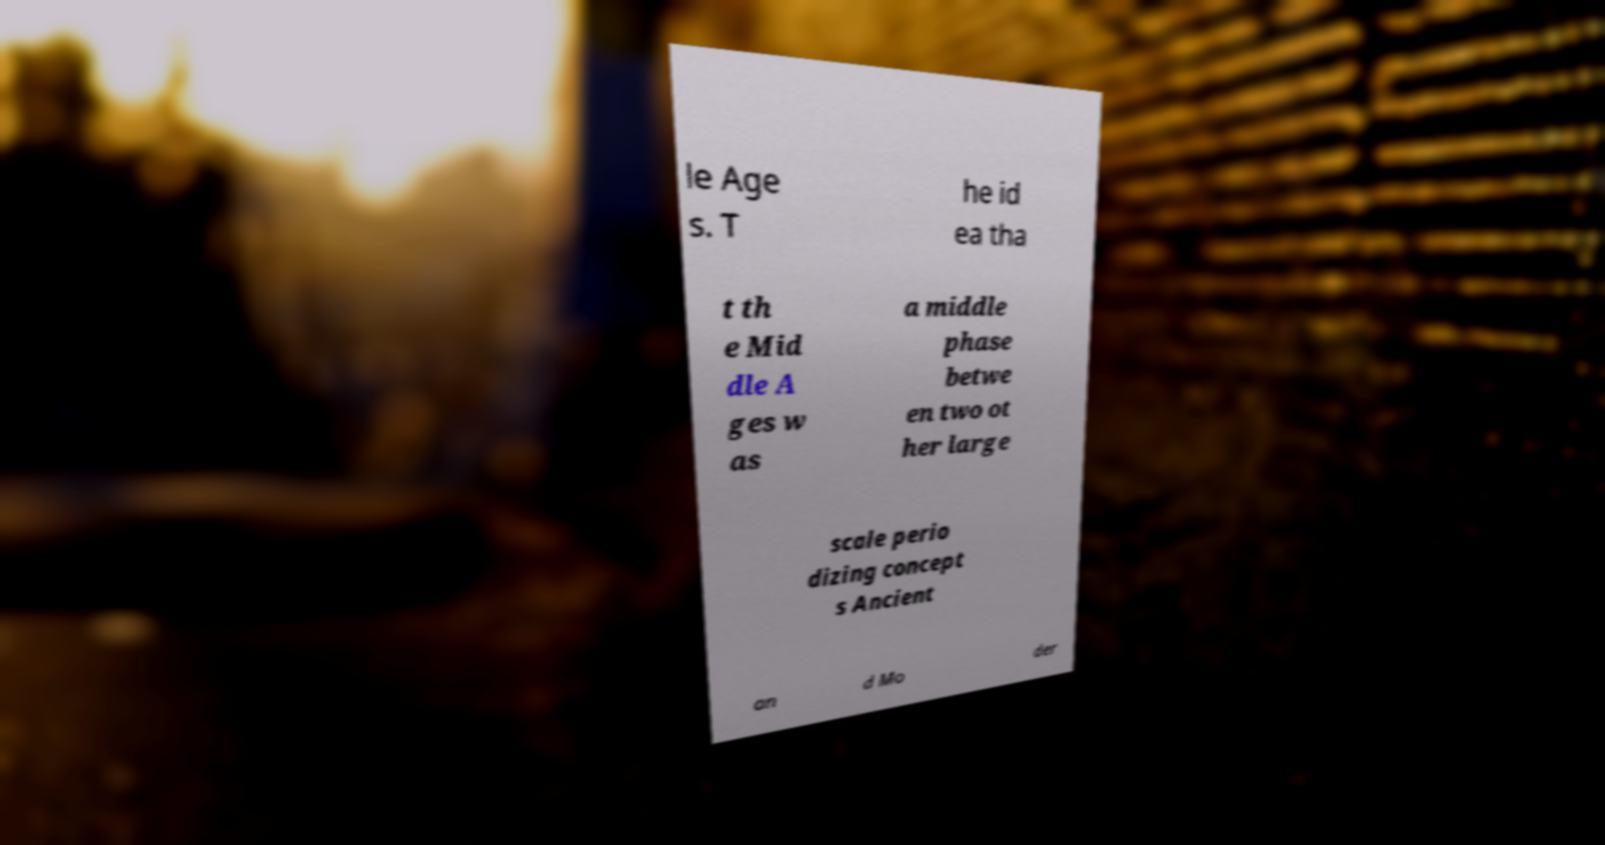Can you accurately transcribe the text from the provided image for me? le Age s. T he id ea tha t th e Mid dle A ges w as a middle phase betwe en two ot her large scale perio dizing concept s Ancient an d Mo der 